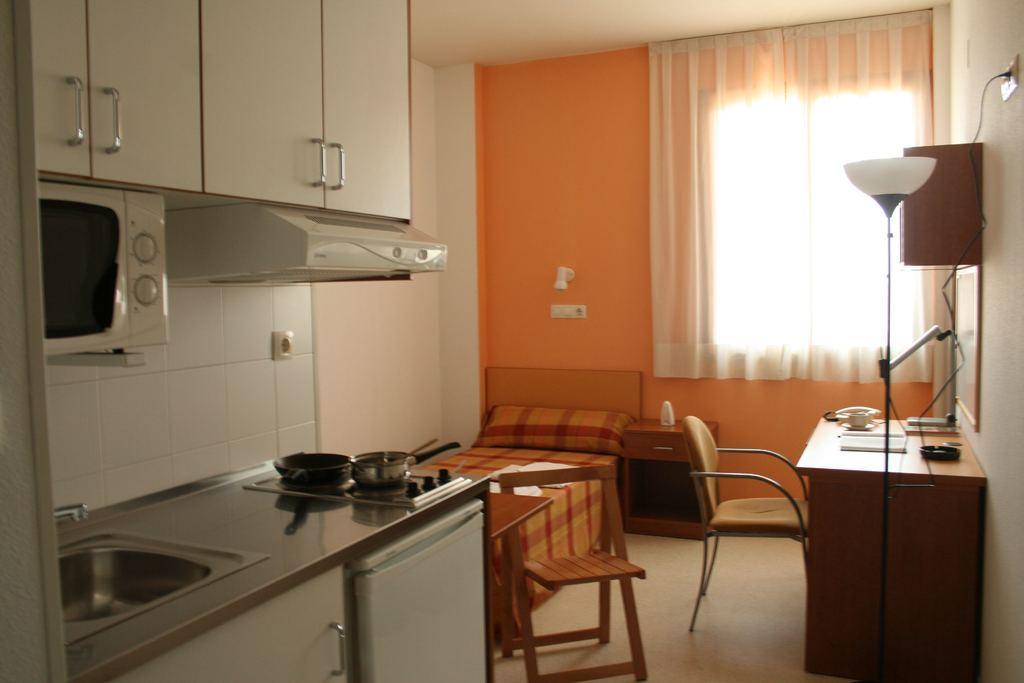Can you describe this image briefly? In the image we can see there is a kitchen and beside it there is a bed and in the opposite there is a table on which there is a table lamp and on the other side there is a white curtain. 